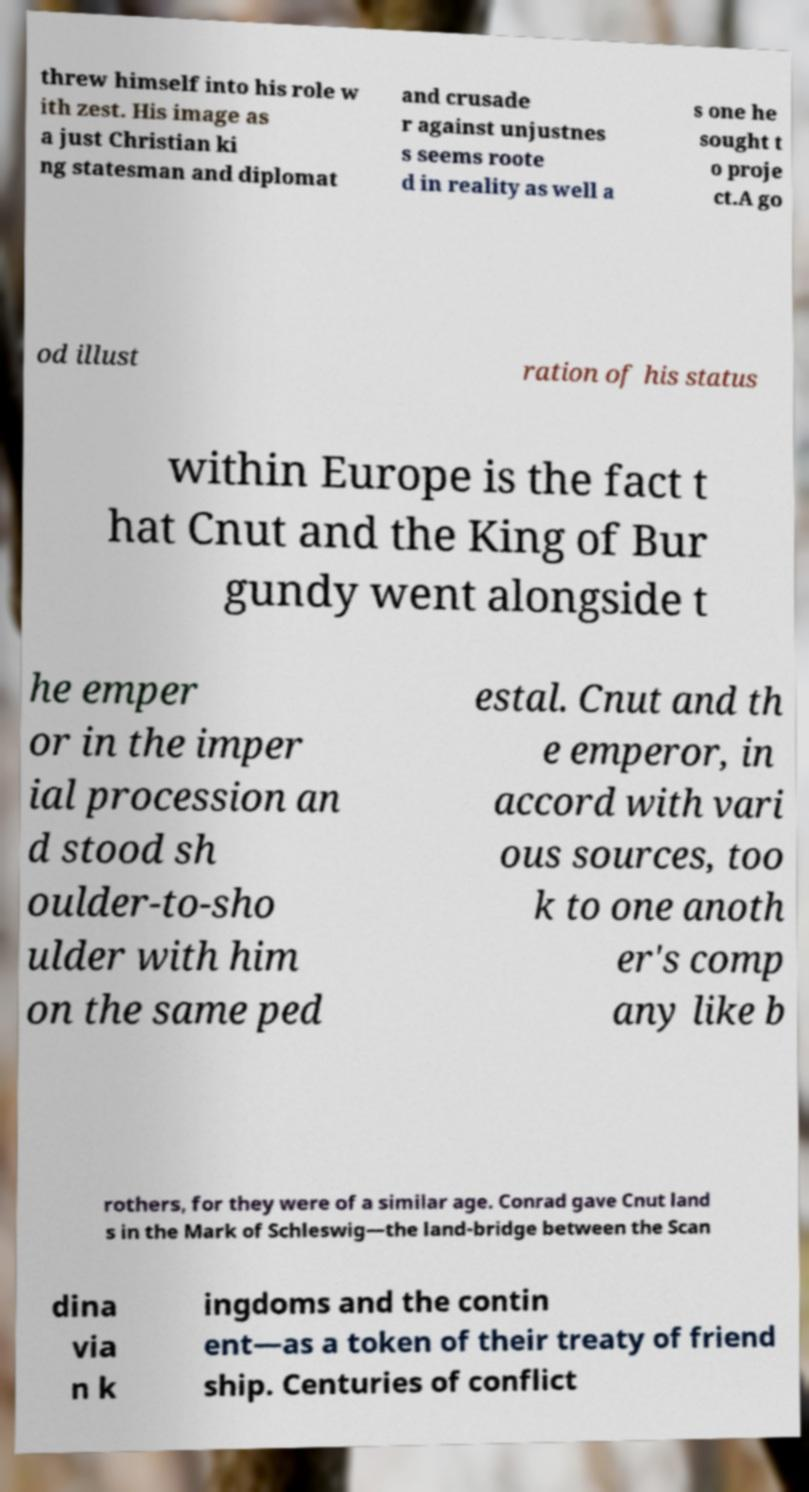What messages or text are displayed in this image? I need them in a readable, typed format. threw himself into his role w ith zest. His image as a just Christian ki ng statesman and diplomat and crusade r against unjustnes s seems roote d in reality as well a s one he sought t o proje ct.A go od illust ration of his status within Europe is the fact t hat Cnut and the King of Bur gundy went alongside t he emper or in the imper ial procession an d stood sh oulder-to-sho ulder with him on the same ped estal. Cnut and th e emperor, in accord with vari ous sources, too k to one anoth er's comp any like b rothers, for they were of a similar age. Conrad gave Cnut land s in the Mark of Schleswig—the land-bridge between the Scan dina via n k ingdoms and the contin ent—as a token of their treaty of friend ship. Centuries of conflict 